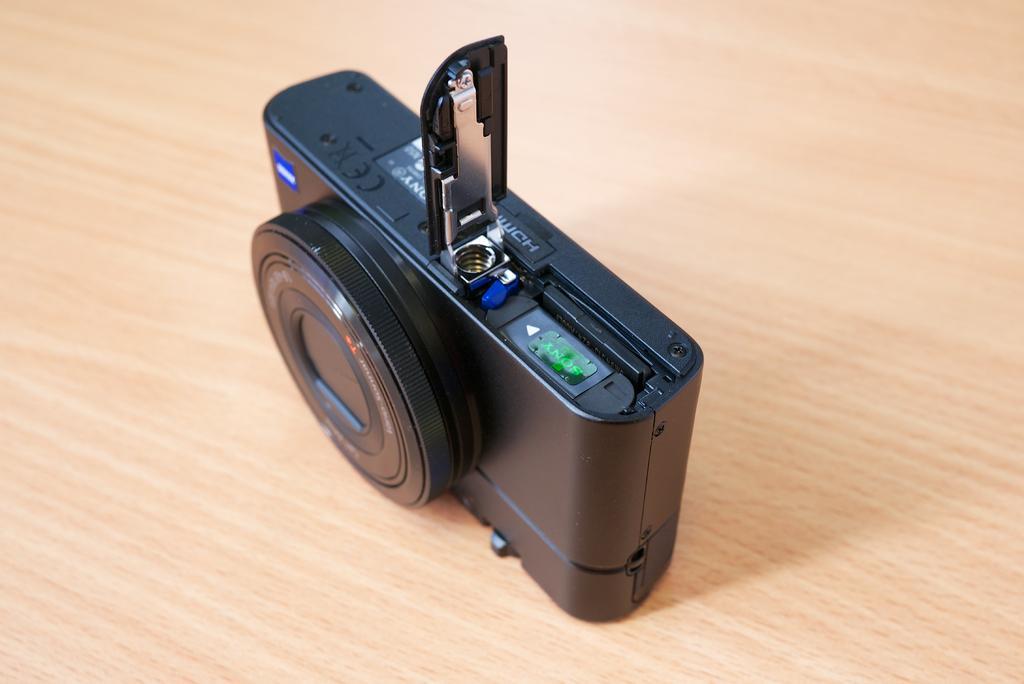In one or two sentences, can you explain what this image depicts? In this image, we can see a camera on the table. 